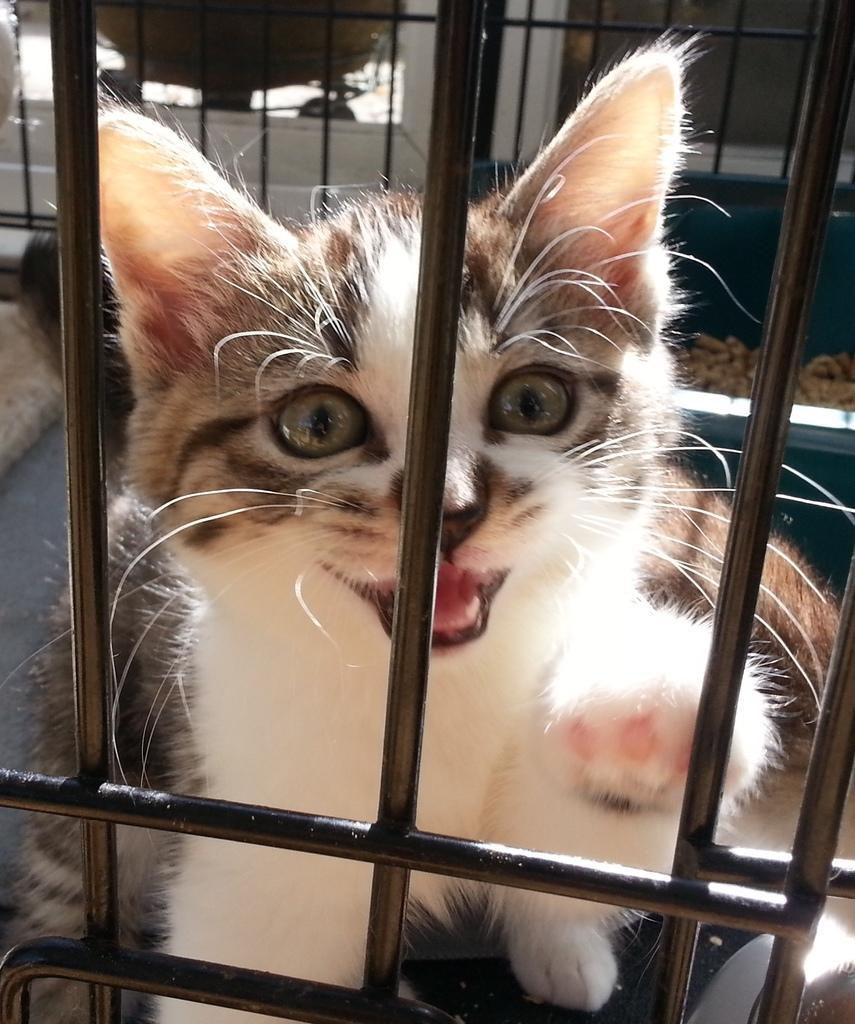Please provide a concise description of this image. In the image there are black rods with fencing. Behind the fencing there is a black and white color cat. Behind the cat there is a fencing. And there are few objects in the background. 